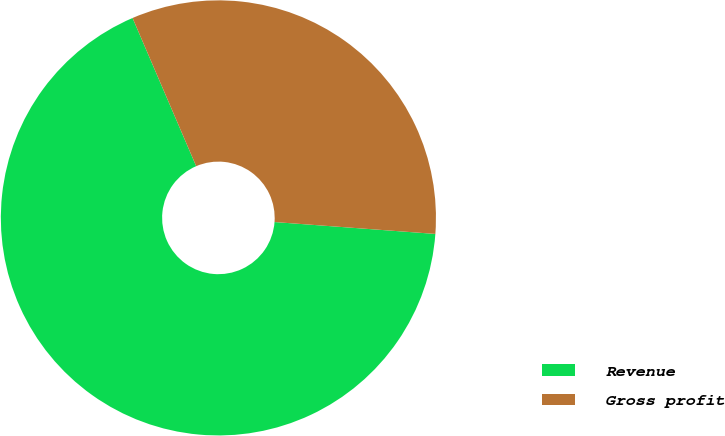Convert chart to OTSL. <chart><loc_0><loc_0><loc_500><loc_500><pie_chart><fcel>Revenue<fcel>Gross profit<nl><fcel>67.37%<fcel>32.63%<nl></chart> 